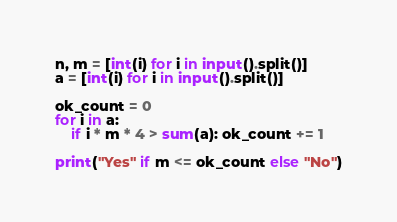<code> <loc_0><loc_0><loc_500><loc_500><_Python_>n, m = [int(i) for i in input().split()]
a = [int(i) for i in input().split()]

ok_count = 0
for i in a:
    if i * m * 4 > sum(a): ok_count += 1

print("Yes" if m <= ok_count else "No")</code> 